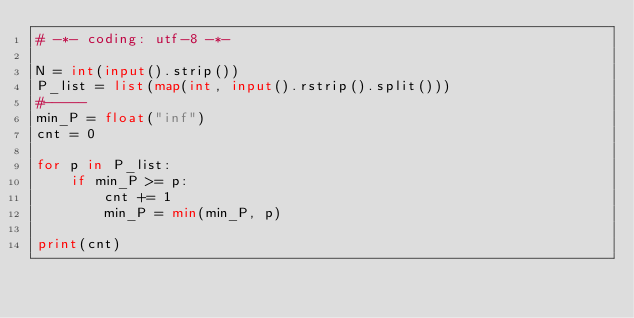<code> <loc_0><loc_0><loc_500><loc_500><_Python_># -*- coding: utf-8 -*-

N = int(input().strip())
P_list = list(map(int, input().rstrip().split()))
#-----
min_P = float("inf")
cnt = 0

for p in P_list:
    if min_P >= p:
        cnt += 1
        min_P = min(min_P, p)

print(cnt)
</code> 